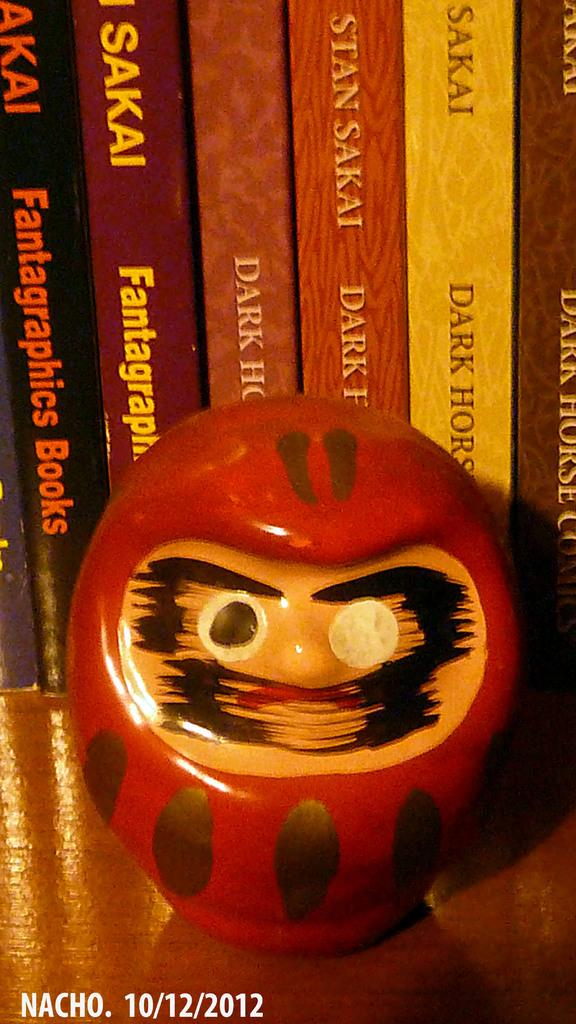<image>
Provide a brief description of the given image. Many books by Stan Sakai are lined up on a shelf. 